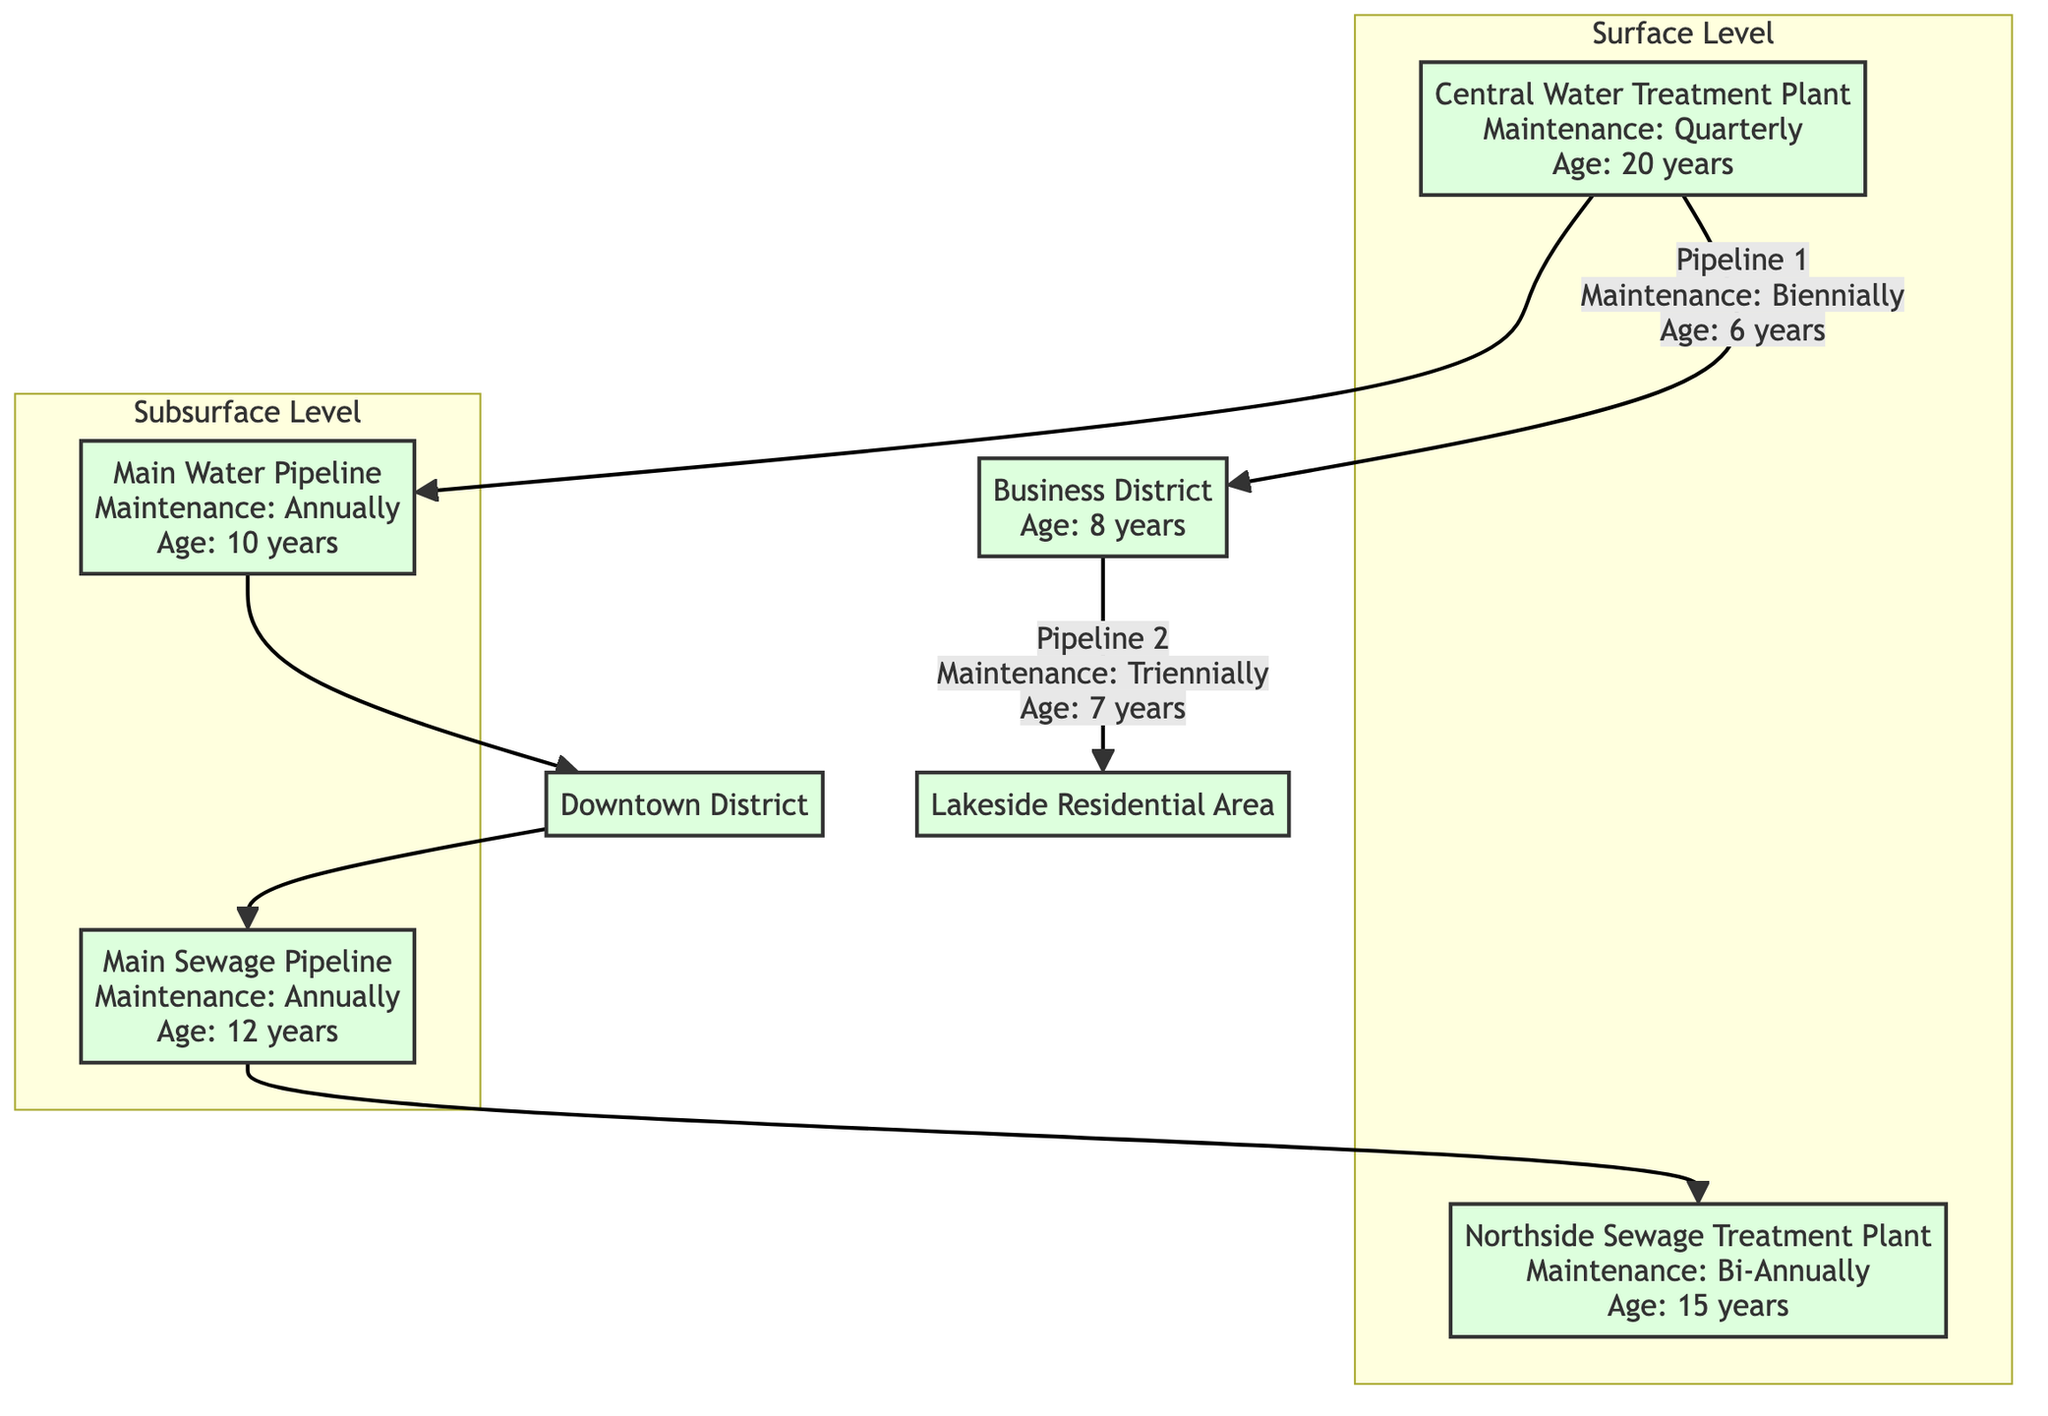What is the maintenance frequency for the Central Water Treatment Plant? The Central Water Treatment Plant, labeled as WTP in the diagram, has a maintenance frequency noted as "Quarterly."
Answer: Quarterly How old is the Main Sewage Pipeline? The Main Sewage Pipeline, marked as MSP, is indicated to be "12 years" old.
Answer: 12 years How many nodes are in the Surface Level subgraph? The Surface Level subgraph consists of two nodes: the Central Water Treatment Plant (WTP) and the Northside Sewage Treatment Plant (STP). Counting these gives a total of two nodes.
Answer: 2 What is the connection point for the Downtown District? The Downtown District (DD) receives water from the Main Water Pipeline (MWP) and is also linked to the Main Sewage Pipeline (MSP). Thus, it serves as a connection point for both pipelines.
Answer: Main Water Pipeline and Main Sewage Pipeline How often is maintenance performed for the Northside Sewage Treatment Plant? The Northside Sewage Treatment Plant (STP) has a maintenance frequency designated as "Bi-Annually."
Answer: Bi-Annually Which residential area connects to the Business District through a pipeline? The Business District (BD) is connected to the Lakeside Residential Area (RA) through Pipeline 2, as shown in the diagram.
Answer: Lakeside Residential Area What is the age of the pipeline connecting BD to RA? The pipeline connecting the Business District (BD) to the Lakeside Residential Area (RA) is noted as being "7 years" old.
Answer: 7 years Which treatment plant is associated with the Downtown District's sewage management? The sewage from the Downtown District (DD) is connected to the Northside Sewage Treatment Plant (STP), as indicated in the diagram.
Answer: Northside Sewage Treatment Plant What is the age of the system for the Main Water Pipeline? The Main Water Pipeline (MWP) is specified to be "10 years" old.
Answer: 10 years 